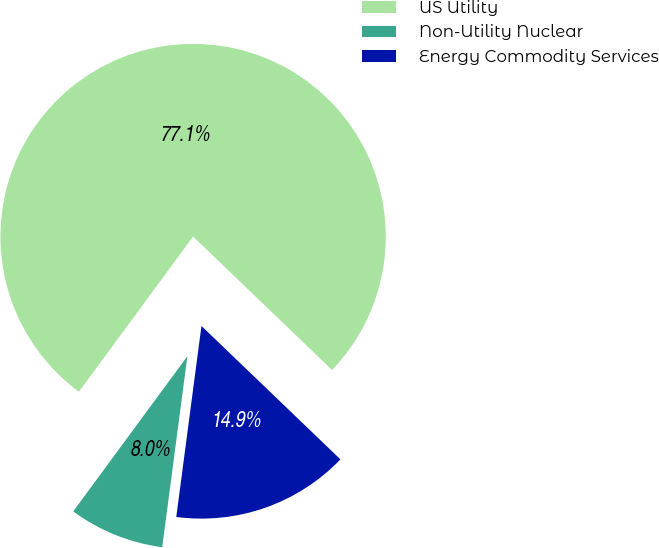<chart> <loc_0><loc_0><loc_500><loc_500><pie_chart><fcel>US Utility<fcel>Non-Utility Nuclear<fcel>Energy Commodity Services<nl><fcel>77.08%<fcel>8.01%<fcel>14.91%<nl></chart> 